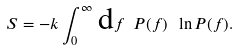Convert formula to latex. <formula><loc_0><loc_0><loc_500><loc_500>S = - k \int _ { 0 } ^ { \infty } \, \text {d} f \ P ( f ) \ \ln P ( f ) .</formula> 